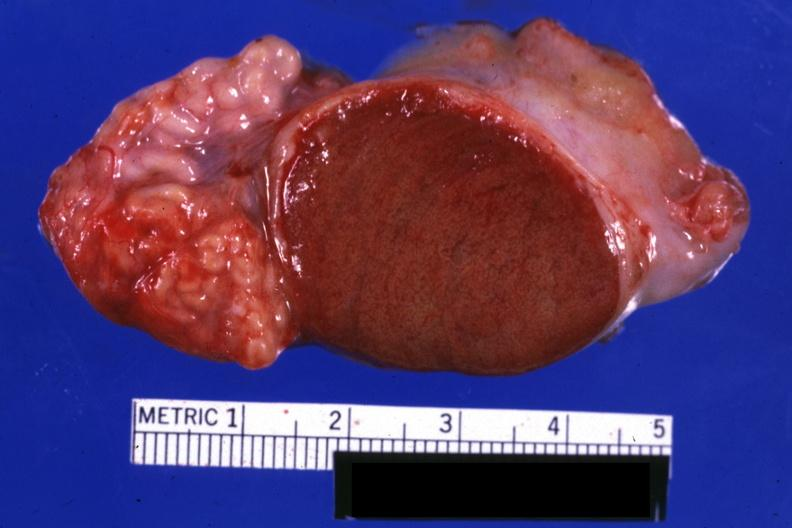what is present?
Answer the question using a single word or phrase. Normal 